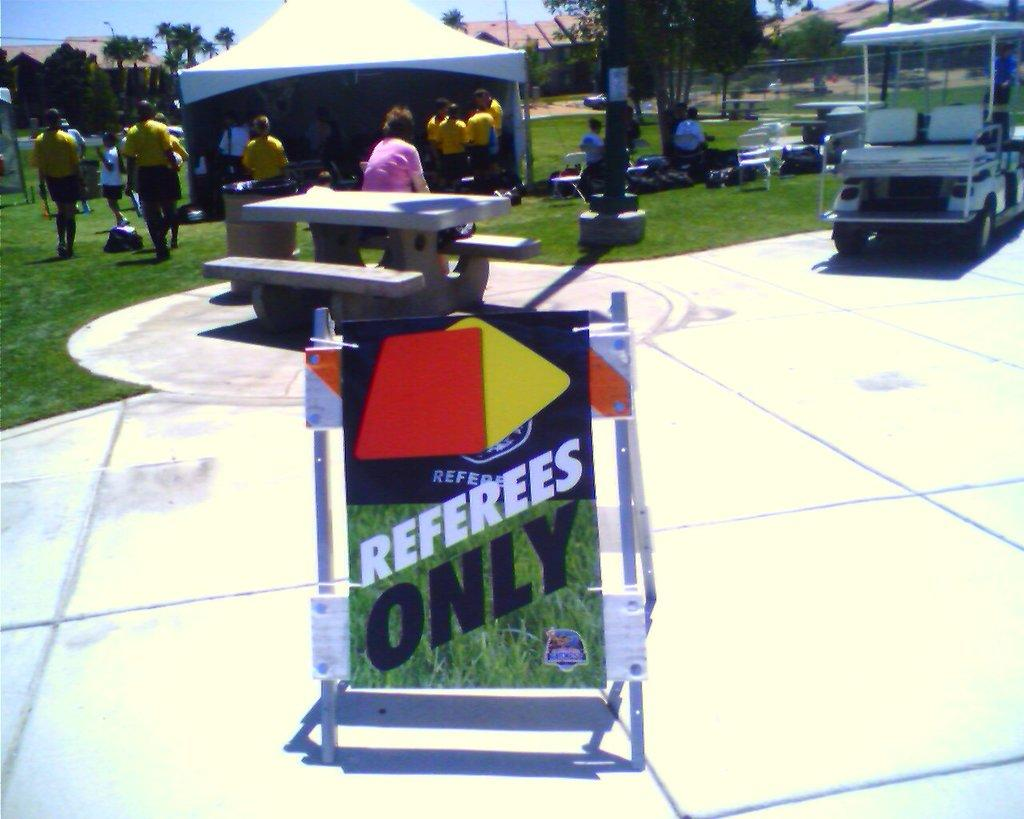<image>
Summarize the visual content of the image. A small sign on a walking path that reads REFEREES ONLY. 